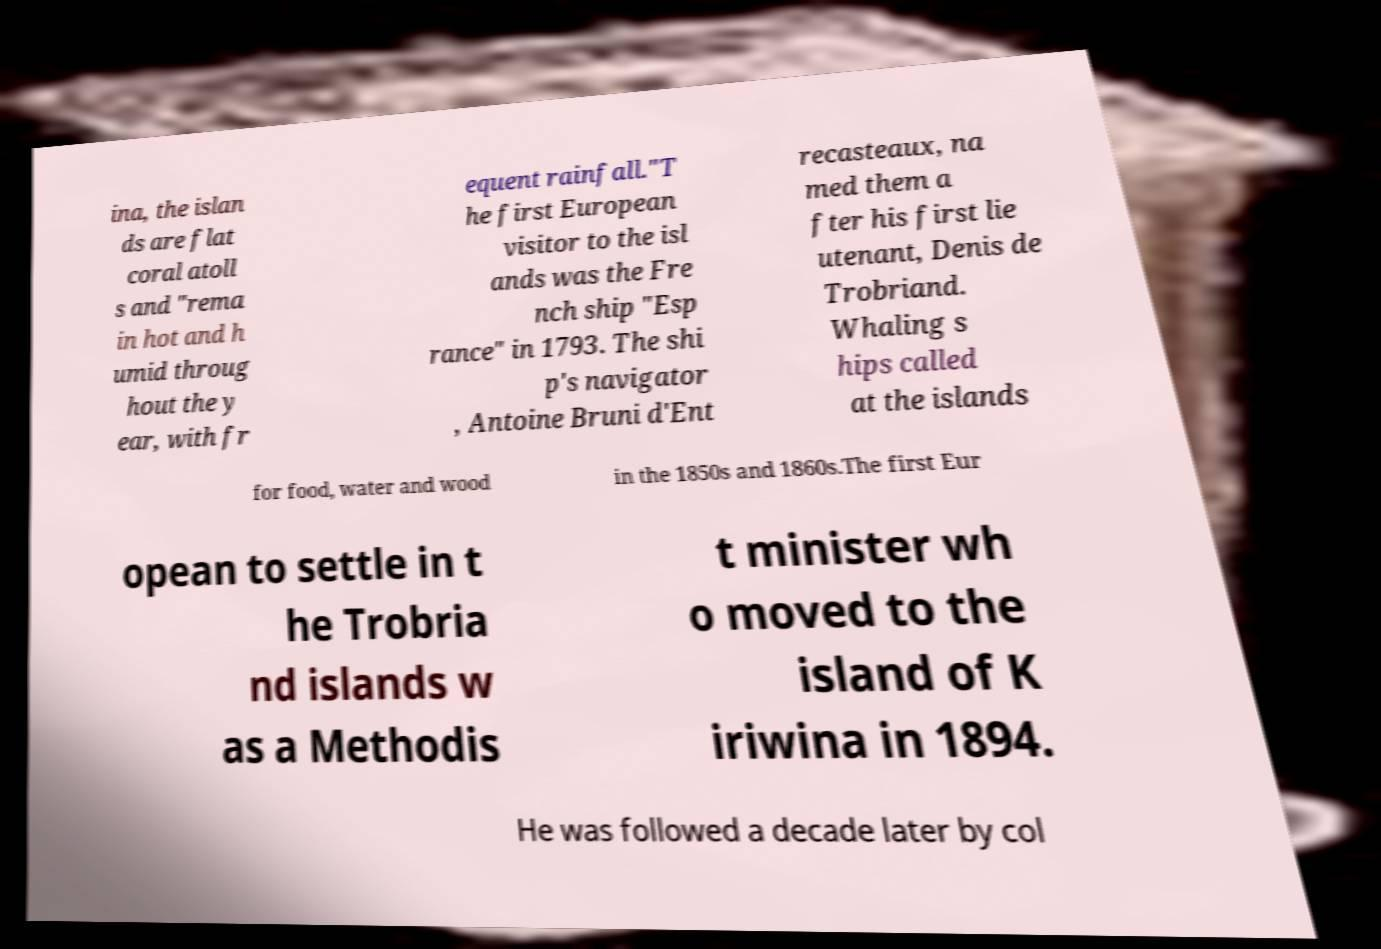Could you extract and type out the text from this image? ina, the islan ds are flat coral atoll s and "rema in hot and h umid throug hout the y ear, with fr equent rainfall."T he first European visitor to the isl ands was the Fre nch ship "Esp rance" in 1793. The shi p's navigator , Antoine Bruni d'Ent recasteaux, na med them a fter his first lie utenant, Denis de Trobriand. Whaling s hips called at the islands for food, water and wood in the 1850s and 1860s.The first Eur opean to settle in t he Trobria nd islands w as a Methodis t minister wh o moved to the island of K iriwina in 1894. He was followed a decade later by col 